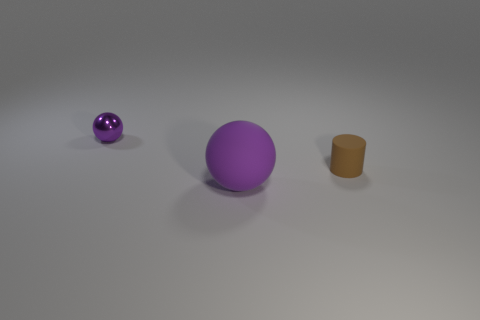Are there any other things that are made of the same material as the tiny sphere?
Provide a short and direct response. No. There is a object that is left of the small brown thing and behind the large rubber ball; what shape is it?
Offer a terse response. Sphere. Are there any small brown matte things in front of the large purple ball?
Provide a short and direct response. No. Is there anything else that is the same shape as the tiny purple metallic thing?
Your response must be concise. Yes. Do the tiny matte thing and the big matte object have the same shape?
Your answer should be very brief. No. Is the number of matte things in front of the big purple ball the same as the number of small brown cylinders on the left side of the tiny cylinder?
Provide a succinct answer. Yes. How many other things are there of the same material as the small purple object?
Your response must be concise. 0. How many big things are gray rubber blocks or rubber objects?
Provide a succinct answer. 1. Are there an equal number of objects that are on the right side of the brown cylinder and big green rubber objects?
Your answer should be very brief. Yes. Is there a large purple sphere right of the purple ball that is right of the shiny ball?
Give a very brief answer. No. 